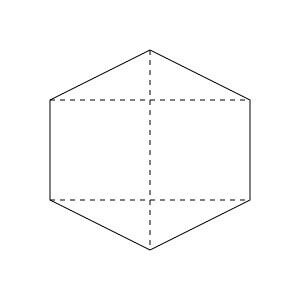In the isometric view of the 3D object shown above, how many faces are visible? To determine the number of visible faces in an isometric view of a 3D object, we need to analyze the diagram step-by-step:

1. Identify the shape: The object appears to be a hexagonal prism.

2. Analyze visible surfaces:
   a. Top face: Visible as the upper hexagon.
   b. Front face: Visible as the rightmost rectangular face.
   c. Side face: Visible as the leftmost rectangular face.

3. Check for hidden faces:
   a. Bottom face: Not visible as it's obscured by the top face.
   b. Back face: Not visible as it's behind the front face.
   c. Other side face: Not visible as it's behind the visible side face.

4. Count the visible faces:
   We can see 3 distinct faces: the top hexagonal face, the front rectangular face, and the side rectangular face.

Therefore, the total number of visible faces in this isometric view is 3.
Answer: 3 